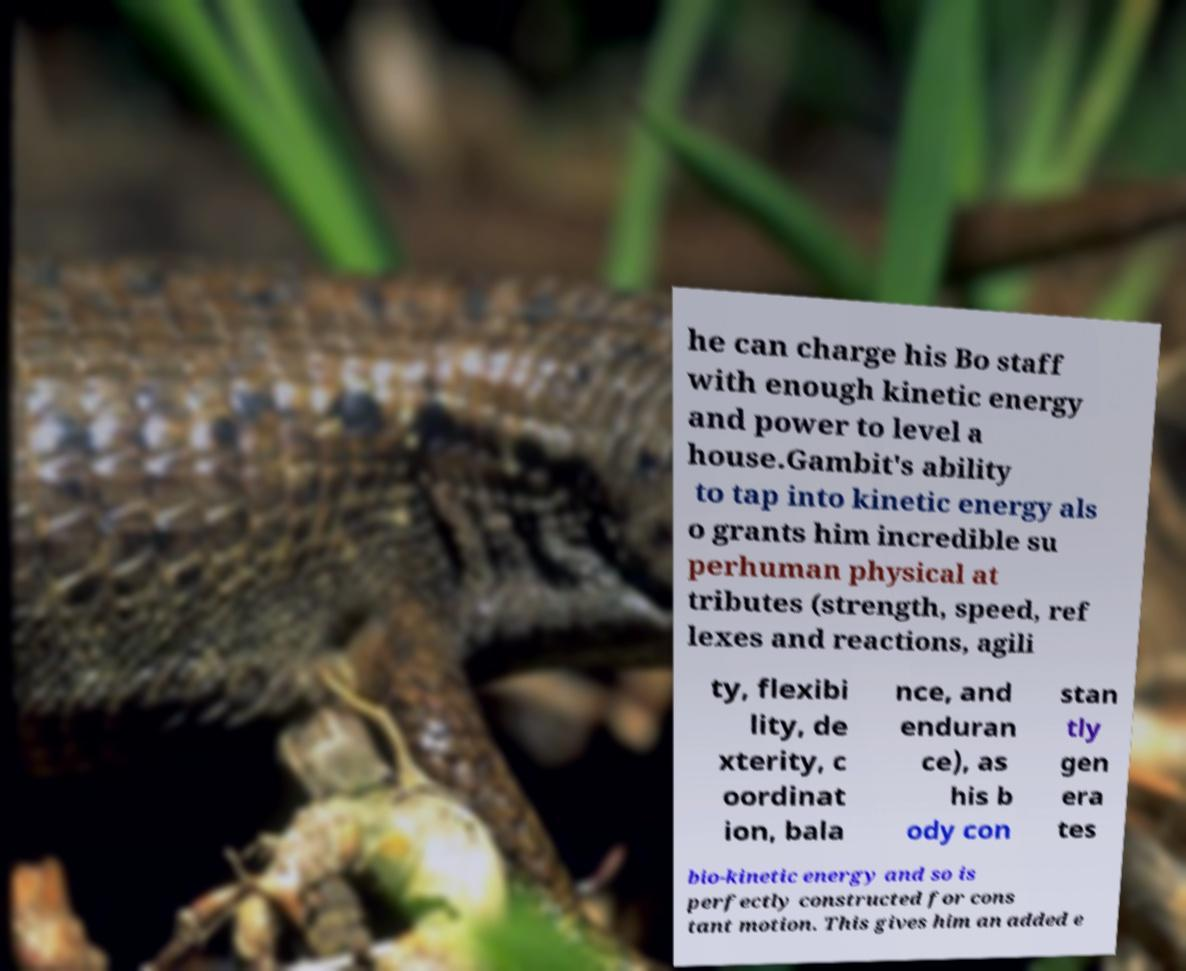There's text embedded in this image that I need extracted. Can you transcribe it verbatim? he can charge his Bo staff with enough kinetic energy and power to level a house.Gambit's ability to tap into kinetic energy als o grants him incredible su perhuman physical at tributes (strength, speed, ref lexes and reactions, agili ty, flexibi lity, de xterity, c oordinat ion, bala nce, and enduran ce), as his b ody con stan tly gen era tes bio-kinetic energy and so is perfectly constructed for cons tant motion. This gives him an added e 